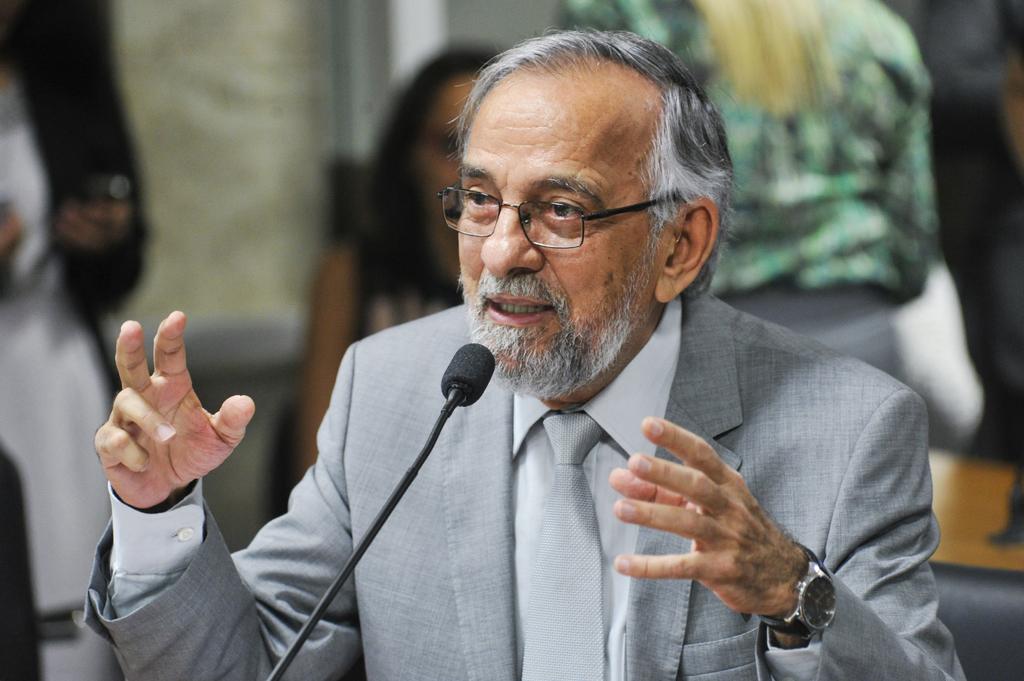Can you describe this image briefly? Here in this picture we can see an old person in a grey suit, speaking something in the microphone present in front of him and we can see he is wearing spectacles on him and behind him also we can see some people sitting and standing over there. 